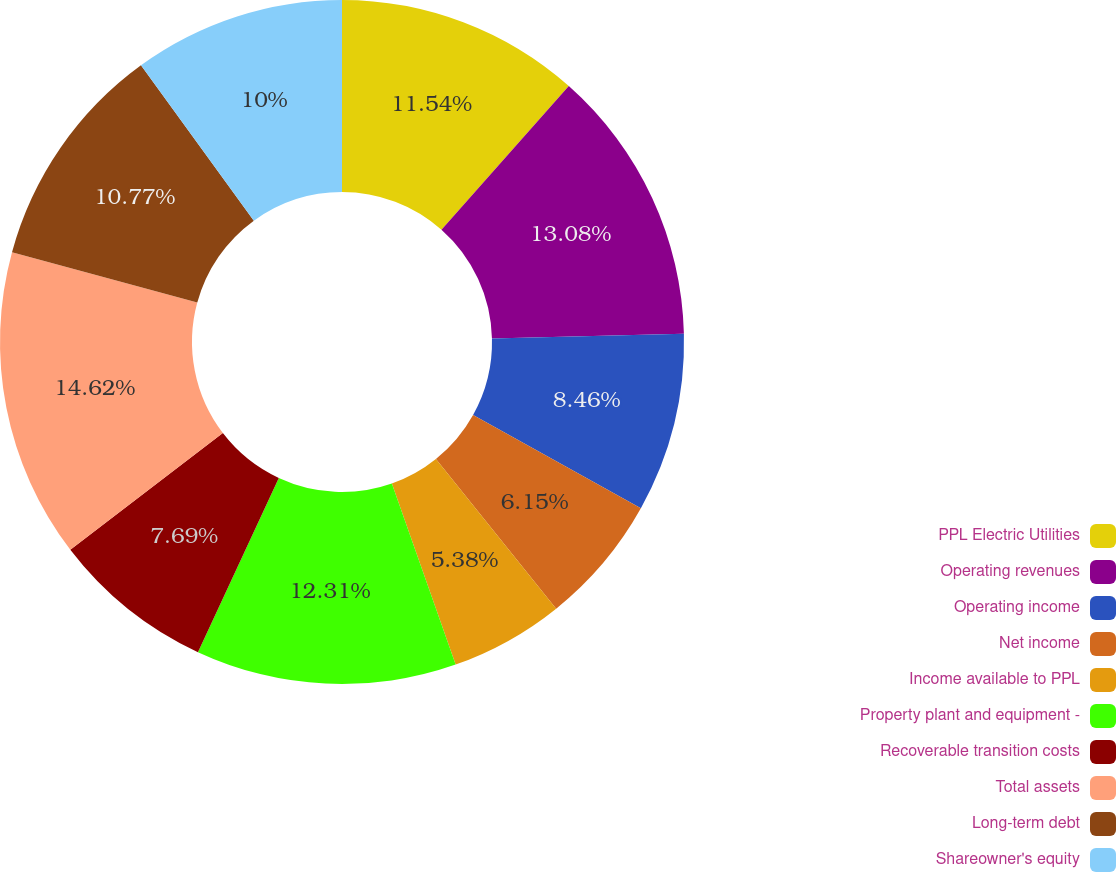Convert chart. <chart><loc_0><loc_0><loc_500><loc_500><pie_chart><fcel>PPL Electric Utilities<fcel>Operating revenues<fcel>Operating income<fcel>Net income<fcel>Income available to PPL<fcel>Property plant and equipment -<fcel>Recoverable transition costs<fcel>Total assets<fcel>Long-term debt<fcel>Shareowner's equity<nl><fcel>11.54%<fcel>13.08%<fcel>8.46%<fcel>6.15%<fcel>5.38%<fcel>12.31%<fcel>7.69%<fcel>14.62%<fcel>10.77%<fcel>10.0%<nl></chart> 